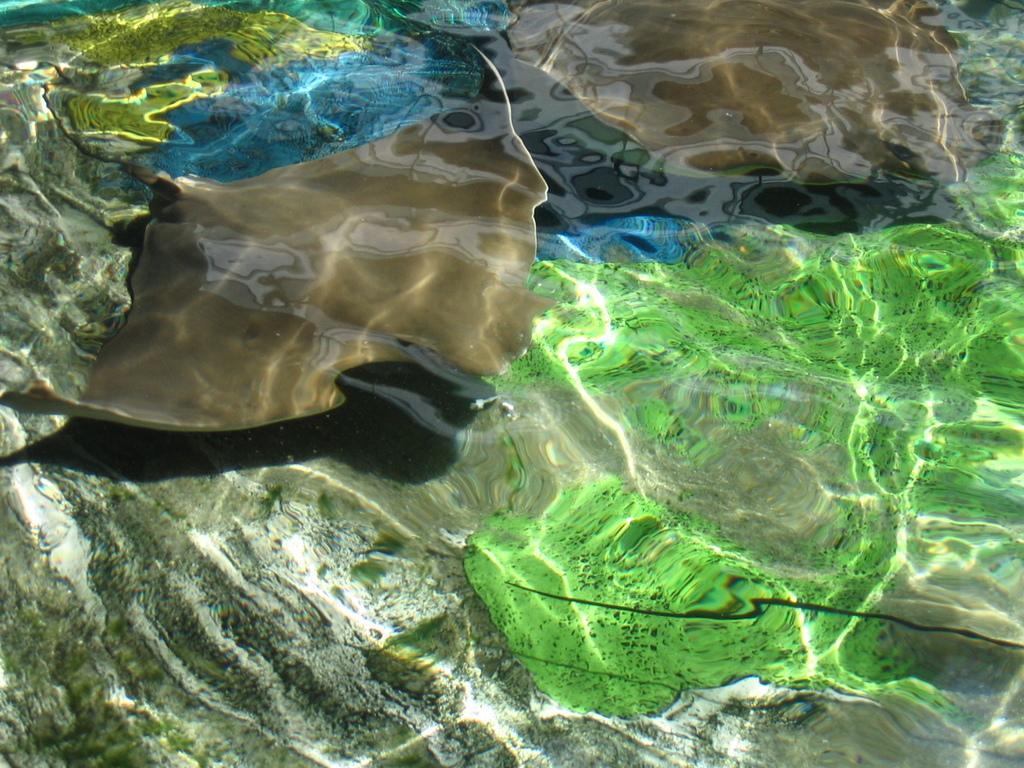Could you give a brief overview of what you see in this image? In this picture we can observe a fish in the water. We can observe green color debris in the water. The fish is in brown color. 